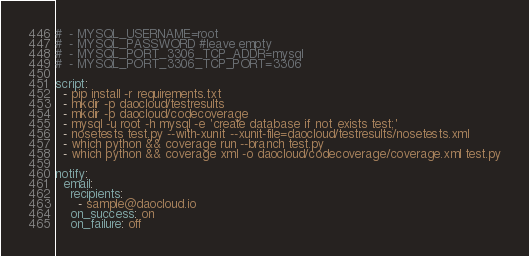Convert code to text. <code><loc_0><loc_0><loc_500><loc_500><_YAML_>#  - MYSQL_USERNAME=root
#  - MYSQL_PASSWORD #leave empty
#  - MYSQL_PORT_3306_TCP_ADDR=mysql
#  - MYSQL_PORT_3306_TCP_PORT=3306

script:
  - pip install -r requirements.txt
  - mkdir -p daocloud/testresults
  - mkdir -p daocloud/codecoverage
  - mysql -u root -h mysql -e 'create database if not exists test;'
  - nosetests test.py --with-xunit --xunit-file=daocloud/testresults/nosetests.xml
  - which python && coverage run --branch test.py
  - which python && coverage xml -o daocloud/codecoverage/coverage.xml test.py

notify:
  email:
    recipients:
      - sample@daocloud.io
    on_success: on
    on_failure: off
</code> 